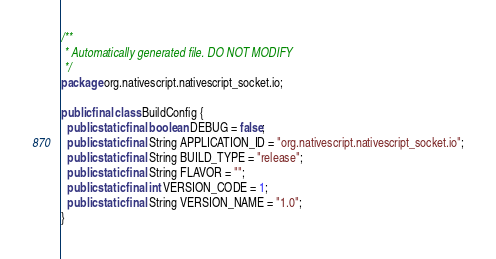<code> <loc_0><loc_0><loc_500><loc_500><_Java_>/**
 * Automatically generated file. DO NOT MODIFY
 */
package org.nativescript.nativescript_socket.io;

public final class BuildConfig {
  public static final boolean DEBUG = false;
  public static final String APPLICATION_ID = "org.nativescript.nativescript_socket.io";
  public static final String BUILD_TYPE = "release";
  public static final String FLAVOR = "";
  public static final int VERSION_CODE = 1;
  public static final String VERSION_NAME = "1.0";
}
</code> 